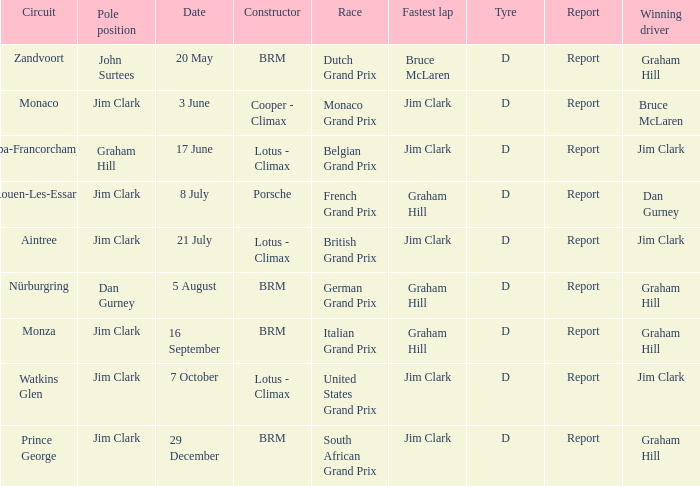What is the tyre on the race where Bruce Mclaren had the fastest lap? D. 